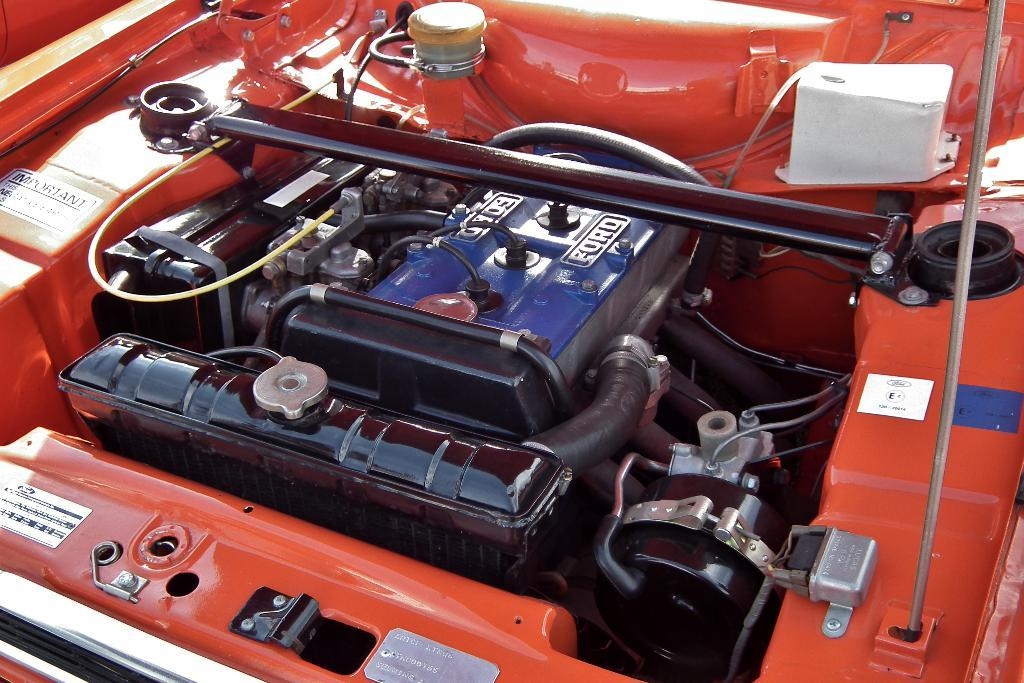What type of object is in the image? There is an engine in the image. What is the origin of the engine? The engine is from a vehicle. What colors can be seen on the engine? The engine has a red color and a black color. What type of pen is visible in the image? There is no pen present in the image; it features an engine from a vehicle. 